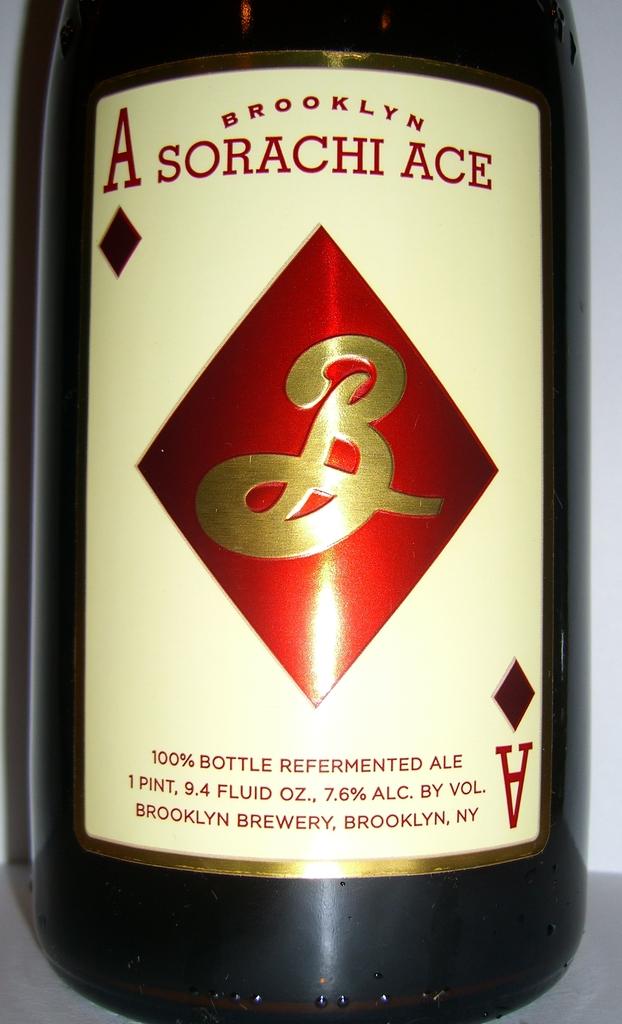Where is this alcohol from?
Offer a very short reply. Brooklyn. What is the name of the drink?
Offer a terse response. Sorachi ace. 